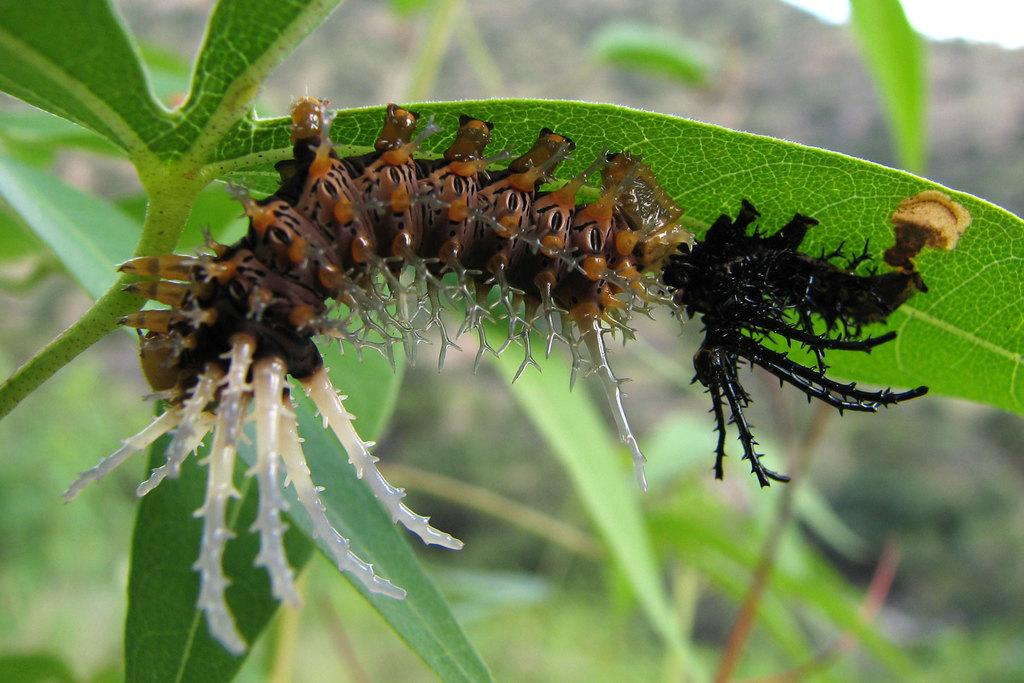What is the main subject of the image? There is a caterpillar on a leaf in the image. What else can be seen in the image besides the caterpillar? There are plants in the image. Can you describe the background of the image? The background of the image is blurry. What color is the shirt worn by the caterpillar in the image? There is no shirt worn by the caterpillar in the image, as it is a small insect and does not wear clothing. 